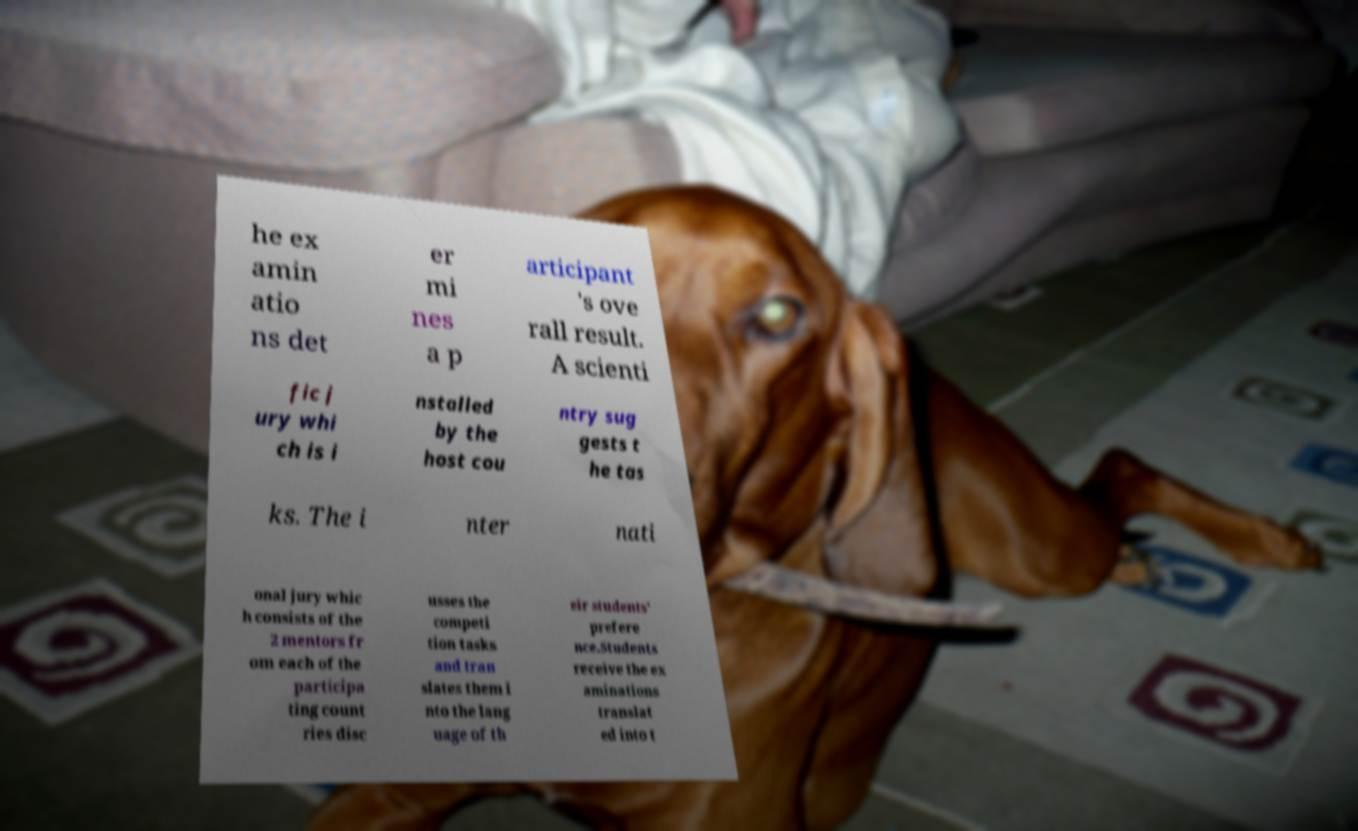Could you assist in decoding the text presented in this image and type it out clearly? he ex amin atio ns det er mi nes a p articipant 's ove rall result. A scienti fic j ury whi ch is i nstalled by the host cou ntry sug gests t he tas ks. The i nter nati onal jury whic h consists of the 2 mentors fr om each of the participa ting count ries disc usses the competi tion tasks and tran slates them i nto the lang uage of th eir students' prefere nce.Students receive the ex aminations translat ed into t 